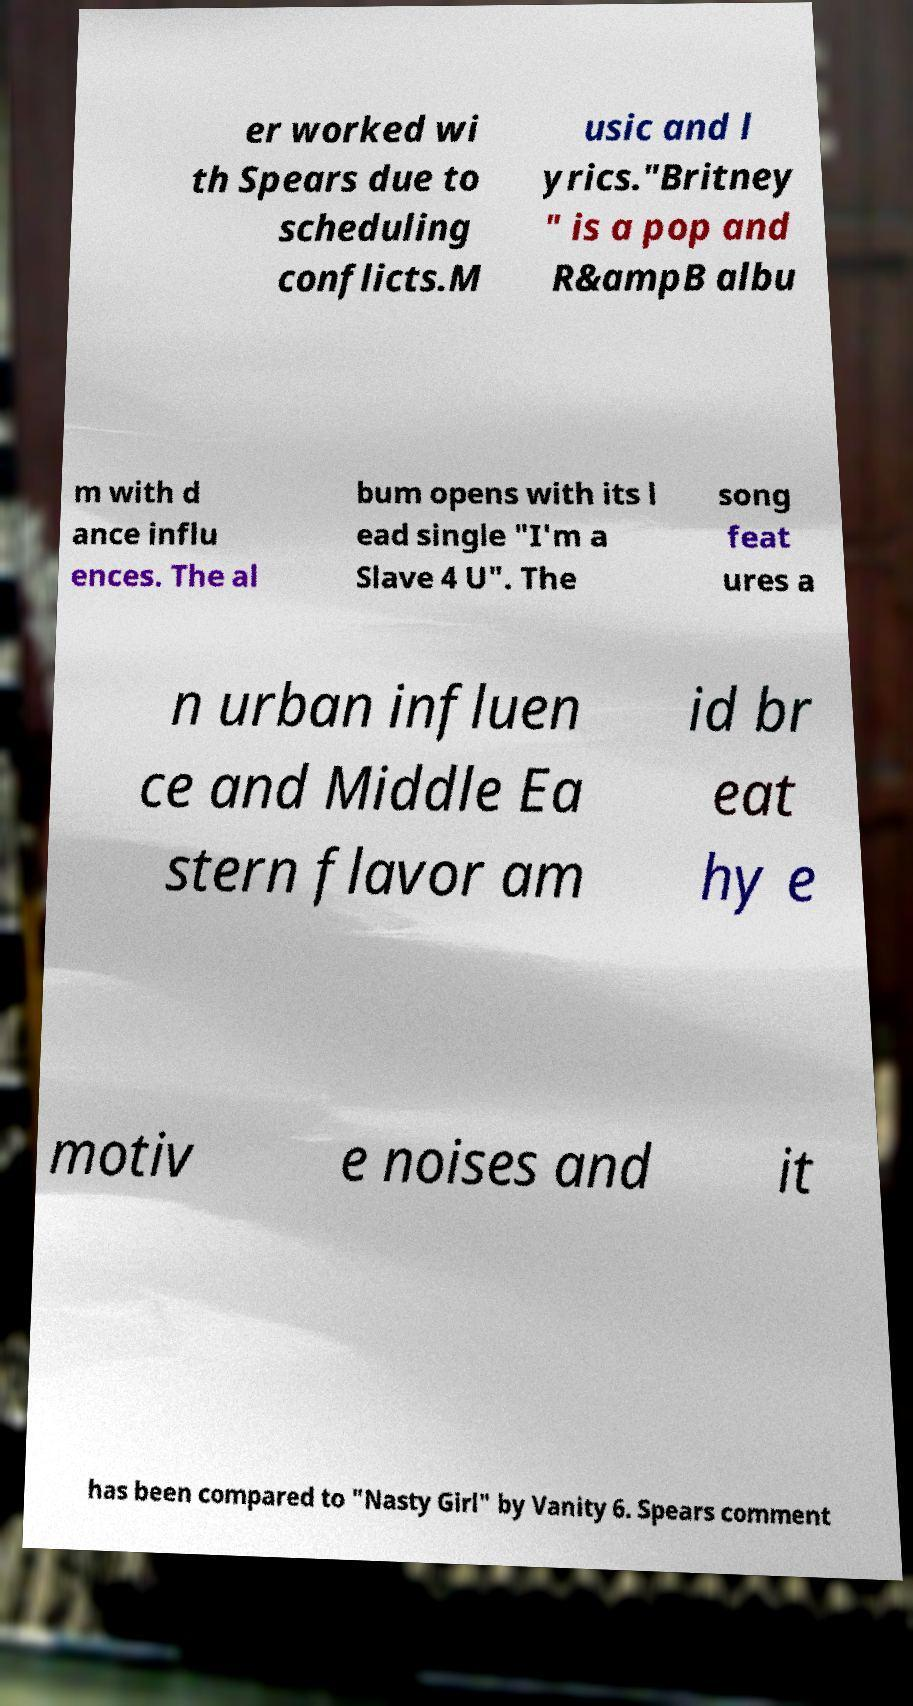Please identify and transcribe the text found in this image. er worked wi th Spears due to scheduling conflicts.M usic and l yrics."Britney " is a pop and R&ampB albu m with d ance influ ences. The al bum opens with its l ead single "I'm a Slave 4 U". The song feat ures a n urban influen ce and Middle Ea stern flavor am id br eat hy e motiv e noises and it has been compared to "Nasty Girl" by Vanity 6. Spears comment 